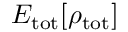<formula> <loc_0><loc_0><loc_500><loc_500>E _ { t o t } [ \rho _ { t o t } ]</formula> 